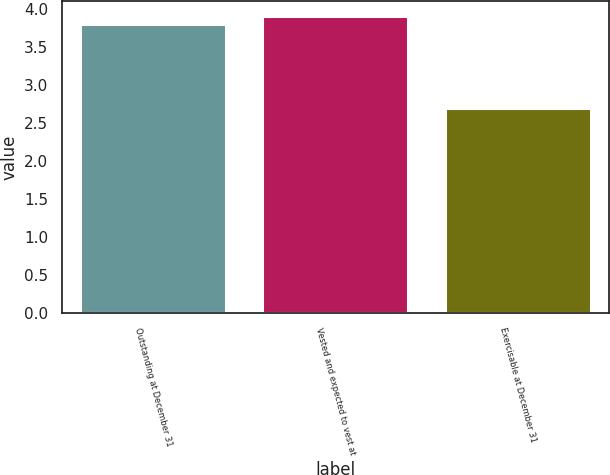Convert chart. <chart><loc_0><loc_0><loc_500><loc_500><bar_chart><fcel>Outstanding at December 31<fcel>Vested and expected to vest at<fcel>Exercisable at December 31<nl><fcel>3.8<fcel>3.91<fcel>2.7<nl></chart> 